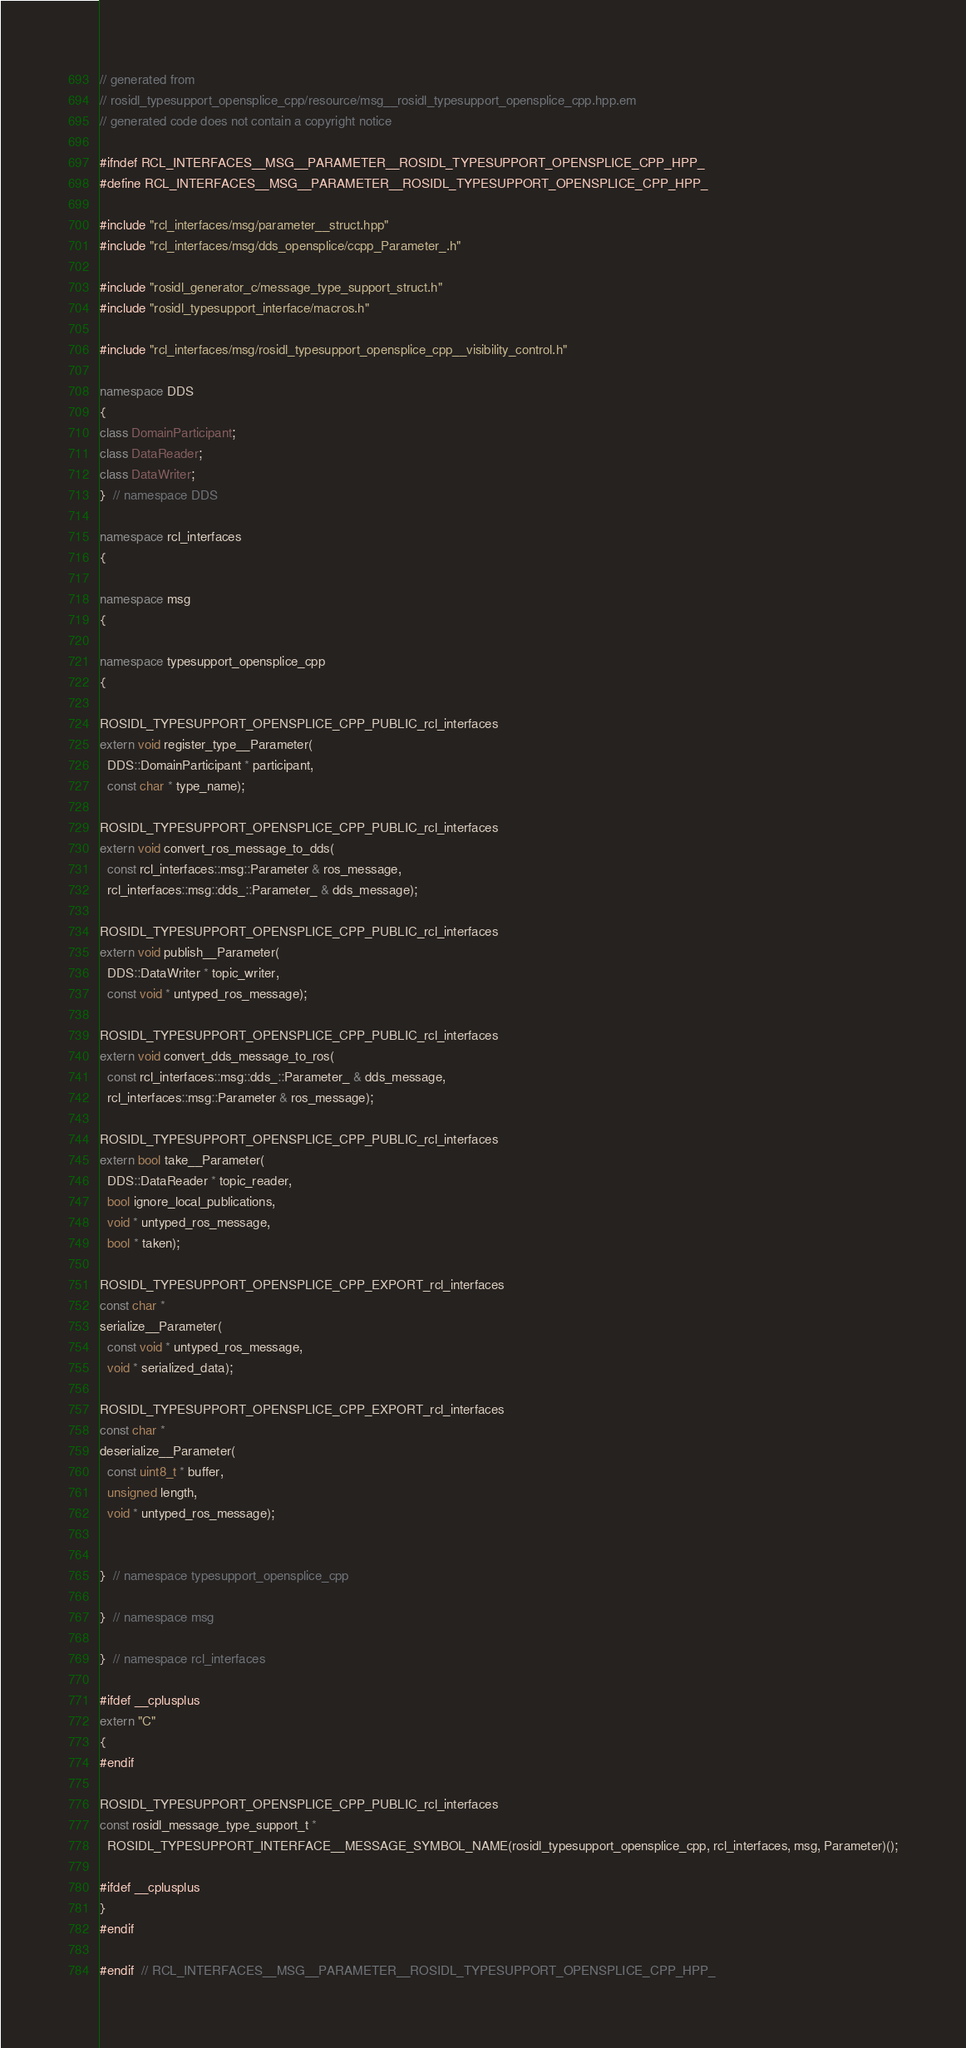Convert code to text. <code><loc_0><loc_0><loc_500><loc_500><_C++_>// generated from
// rosidl_typesupport_opensplice_cpp/resource/msg__rosidl_typesupport_opensplice_cpp.hpp.em
// generated code does not contain a copyright notice

#ifndef RCL_INTERFACES__MSG__PARAMETER__ROSIDL_TYPESUPPORT_OPENSPLICE_CPP_HPP_
#define RCL_INTERFACES__MSG__PARAMETER__ROSIDL_TYPESUPPORT_OPENSPLICE_CPP_HPP_

#include "rcl_interfaces/msg/parameter__struct.hpp"
#include "rcl_interfaces/msg/dds_opensplice/ccpp_Parameter_.h"

#include "rosidl_generator_c/message_type_support_struct.h"
#include "rosidl_typesupport_interface/macros.h"

#include "rcl_interfaces/msg/rosidl_typesupport_opensplice_cpp__visibility_control.h"

namespace DDS
{
class DomainParticipant;
class DataReader;
class DataWriter;
}  // namespace DDS

namespace rcl_interfaces
{

namespace msg
{

namespace typesupport_opensplice_cpp
{

ROSIDL_TYPESUPPORT_OPENSPLICE_CPP_PUBLIC_rcl_interfaces
extern void register_type__Parameter(
  DDS::DomainParticipant * participant,
  const char * type_name);

ROSIDL_TYPESUPPORT_OPENSPLICE_CPP_PUBLIC_rcl_interfaces
extern void convert_ros_message_to_dds(
  const rcl_interfaces::msg::Parameter & ros_message,
  rcl_interfaces::msg::dds_::Parameter_ & dds_message);

ROSIDL_TYPESUPPORT_OPENSPLICE_CPP_PUBLIC_rcl_interfaces
extern void publish__Parameter(
  DDS::DataWriter * topic_writer,
  const void * untyped_ros_message);

ROSIDL_TYPESUPPORT_OPENSPLICE_CPP_PUBLIC_rcl_interfaces
extern void convert_dds_message_to_ros(
  const rcl_interfaces::msg::dds_::Parameter_ & dds_message,
  rcl_interfaces::msg::Parameter & ros_message);

ROSIDL_TYPESUPPORT_OPENSPLICE_CPP_PUBLIC_rcl_interfaces
extern bool take__Parameter(
  DDS::DataReader * topic_reader,
  bool ignore_local_publications,
  void * untyped_ros_message,
  bool * taken);

ROSIDL_TYPESUPPORT_OPENSPLICE_CPP_EXPORT_rcl_interfaces
const char *
serialize__Parameter(
  const void * untyped_ros_message,
  void * serialized_data);

ROSIDL_TYPESUPPORT_OPENSPLICE_CPP_EXPORT_rcl_interfaces
const char *
deserialize__Parameter(
  const uint8_t * buffer,
  unsigned length,
  void * untyped_ros_message);


}  // namespace typesupport_opensplice_cpp

}  // namespace msg

}  // namespace rcl_interfaces

#ifdef __cplusplus
extern "C"
{
#endif

ROSIDL_TYPESUPPORT_OPENSPLICE_CPP_PUBLIC_rcl_interfaces
const rosidl_message_type_support_t *
  ROSIDL_TYPESUPPORT_INTERFACE__MESSAGE_SYMBOL_NAME(rosidl_typesupport_opensplice_cpp, rcl_interfaces, msg, Parameter)();

#ifdef __cplusplus
}
#endif

#endif  // RCL_INTERFACES__MSG__PARAMETER__ROSIDL_TYPESUPPORT_OPENSPLICE_CPP_HPP_
</code> 